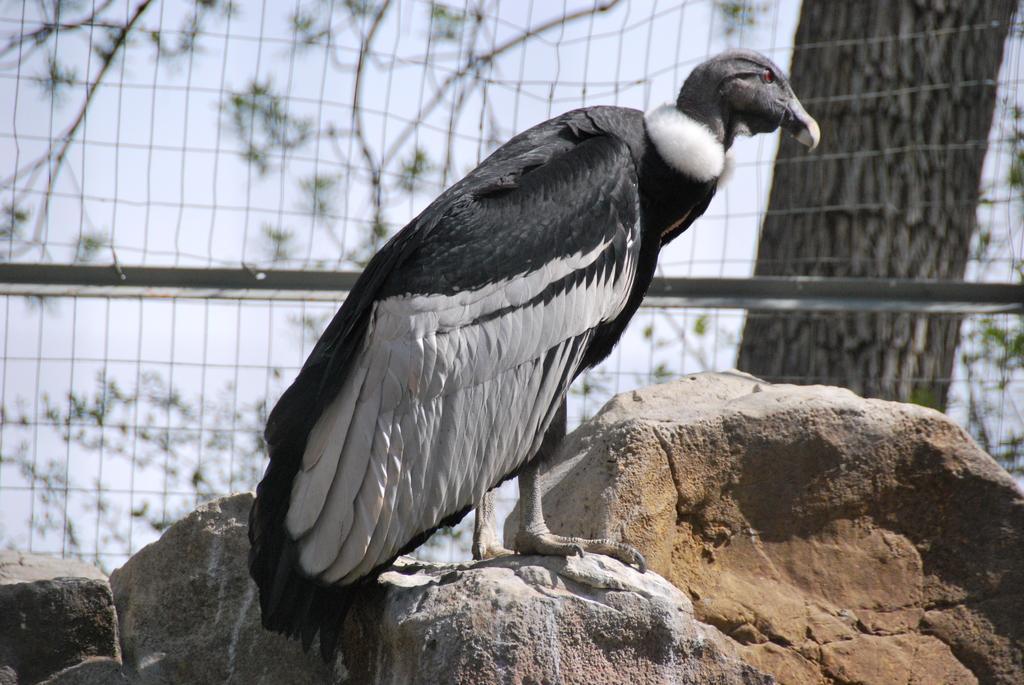In one or two sentences, can you explain what this image depicts? In this image I can see a bird. In the background, I can see a mesh and a tree. 